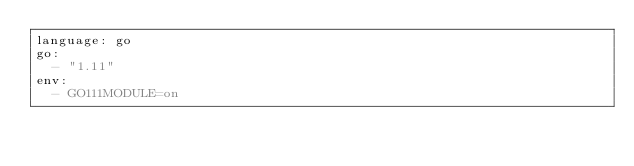Convert code to text. <code><loc_0><loc_0><loc_500><loc_500><_YAML_>language: go
go:
  - "1.11"
env:
  - GO111MODULE=on
</code> 